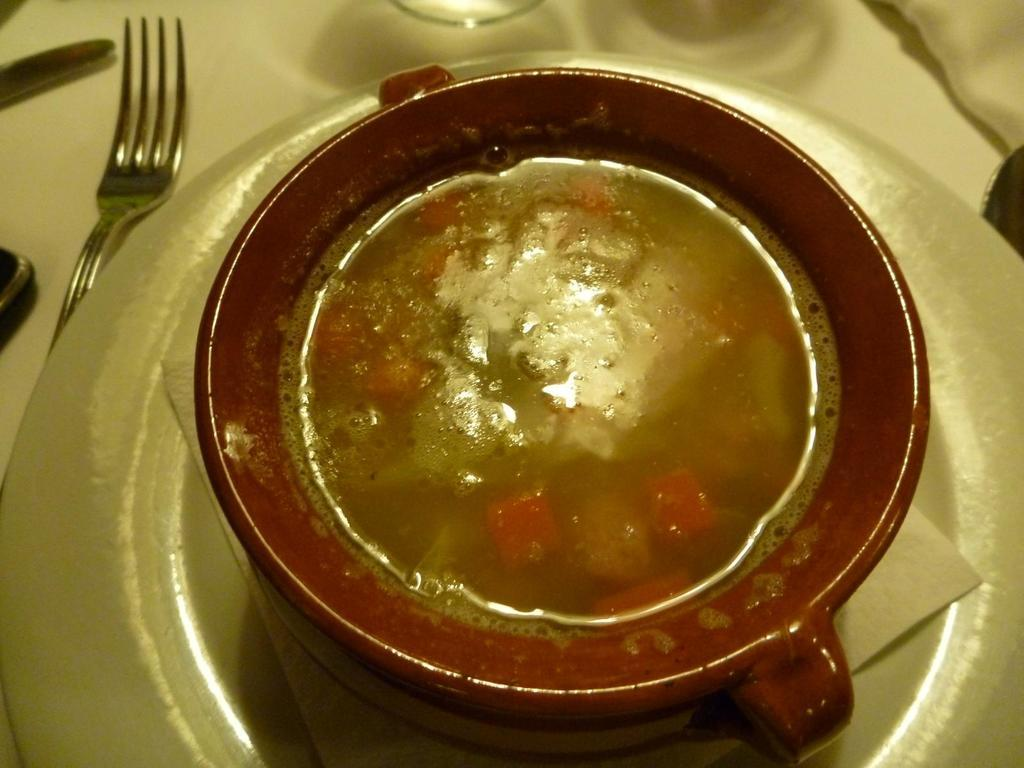What is present on the plate in the image? There is no specific information about what is on the plate in the image. What type of material is used for the tissue paper in the image? The facts do not specify the type of material for the tissue paper. What is the cup in the image used for? The purpose of the cup in the image is not mentioned in the facts. What is the fork used for in the image? The fork in the image is likely used for eating the food on the platform. What is the food on the platform in the image? The facts do not specify the type of food on the platform. How many eyes can be seen on the fork in the image? There are no eyes present on the fork in the image. What type of pin is used to hold the tissue paper in place in the image? There is no pin mentioned or visible in the image. 